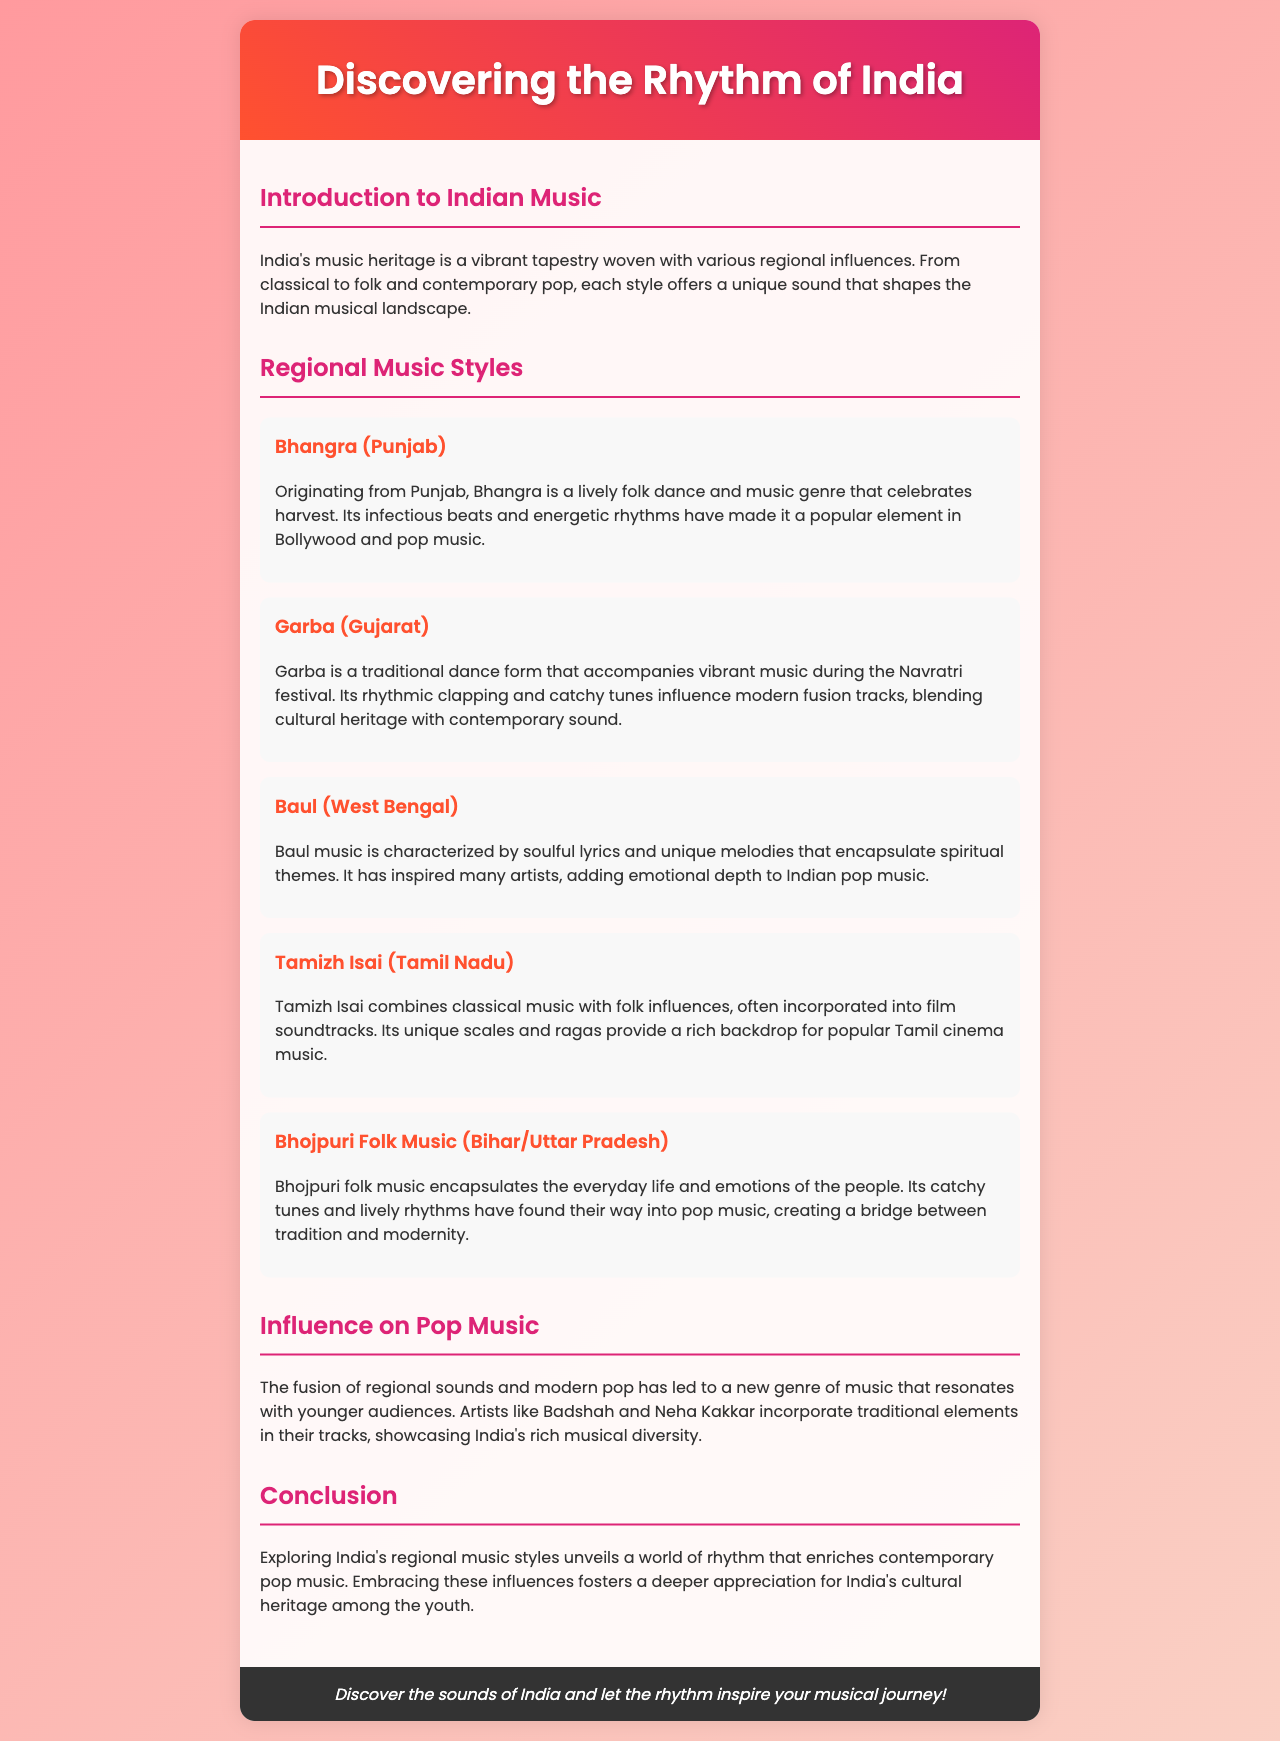What is the title of the brochure? The title is clearly stated in the header of the document, making it easy to identify the main theme.
Answer: Discovering the Rhythm of India What regional music style originates from Punjab? This information is provided in the section about Regional Music Styles, specifically identifying Bhangra.
Answer: Bhangra Which festival is Garba associated with? The document explicitly mentions that Garba music accompanies vibrant celebrations during a specific festival.
Answer: Navratri What type of music is Tamizh Isai a combination of? The document details that Tamizh Isai combines two distinct music styles, providing insight into its musical roots.
Answer: Classical music and folk influences Who are two artists mentioned that incorporate traditional elements into their pop music? This question requires connecting the influence of regional music on contemporary pop, as mentioned in the Influence on Pop Music section.
Answer: Badshah and Neha Kakkar Which state is associated with Bhojpuri folk music? The document specifies the regions where Bhojpuri folk music is prevalent, making it easy to pinpoint its origins.
Answer: Bihar/Uttar Pradesh What describes Baul music? The characteristics of Baul music are noted in its description, revealing what makes it special and influential.
Answer: Soulful lyrics and unique melodies How does the brochure describe the influence of regional music on contemporary pop? This question encourages readers to consider the broader impact of regional music as summarized in the conclusion.
Answer: Enriches contemporary pop music 